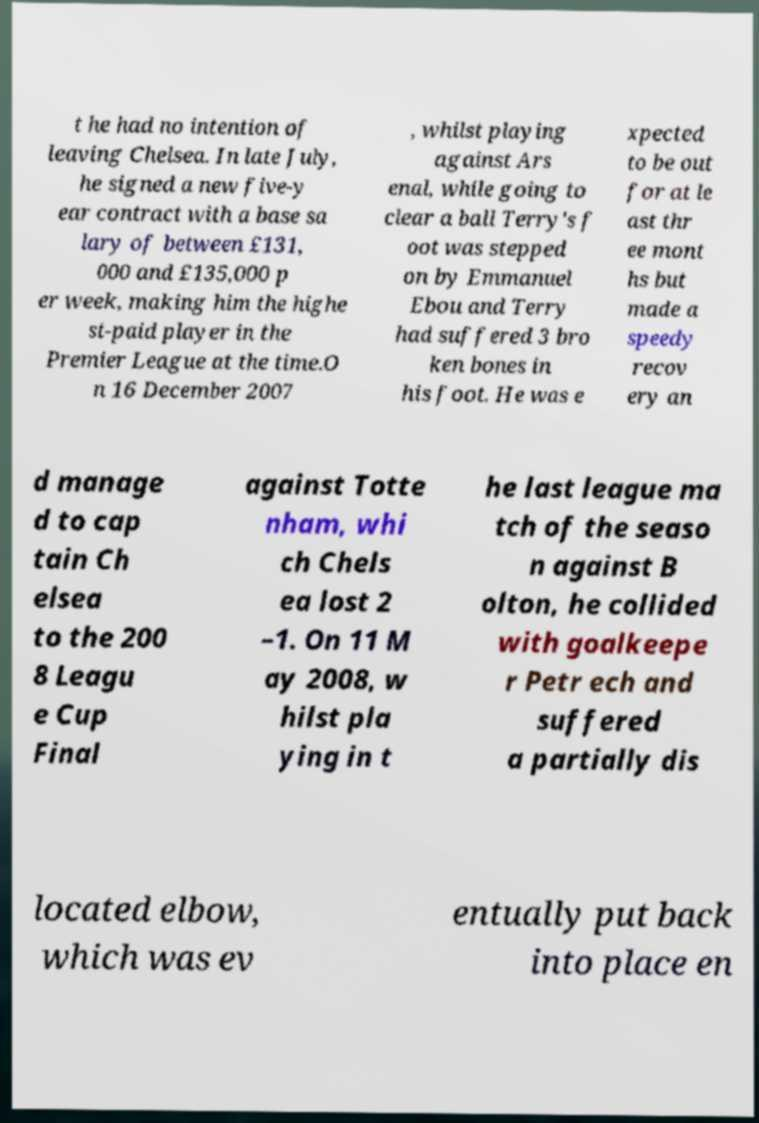There's text embedded in this image that I need extracted. Can you transcribe it verbatim? t he had no intention of leaving Chelsea. In late July, he signed a new five-y ear contract with a base sa lary of between £131, 000 and £135,000 p er week, making him the highe st-paid player in the Premier League at the time.O n 16 December 2007 , whilst playing against Ars enal, while going to clear a ball Terry's f oot was stepped on by Emmanuel Ebou and Terry had suffered 3 bro ken bones in his foot. He was e xpected to be out for at le ast thr ee mont hs but made a speedy recov ery an d manage d to cap tain Ch elsea to the 200 8 Leagu e Cup Final against Totte nham, whi ch Chels ea lost 2 –1. On 11 M ay 2008, w hilst pla ying in t he last league ma tch of the seaso n against B olton, he collided with goalkeepe r Petr ech and suffered a partially dis located elbow, which was ev entually put back into place en 